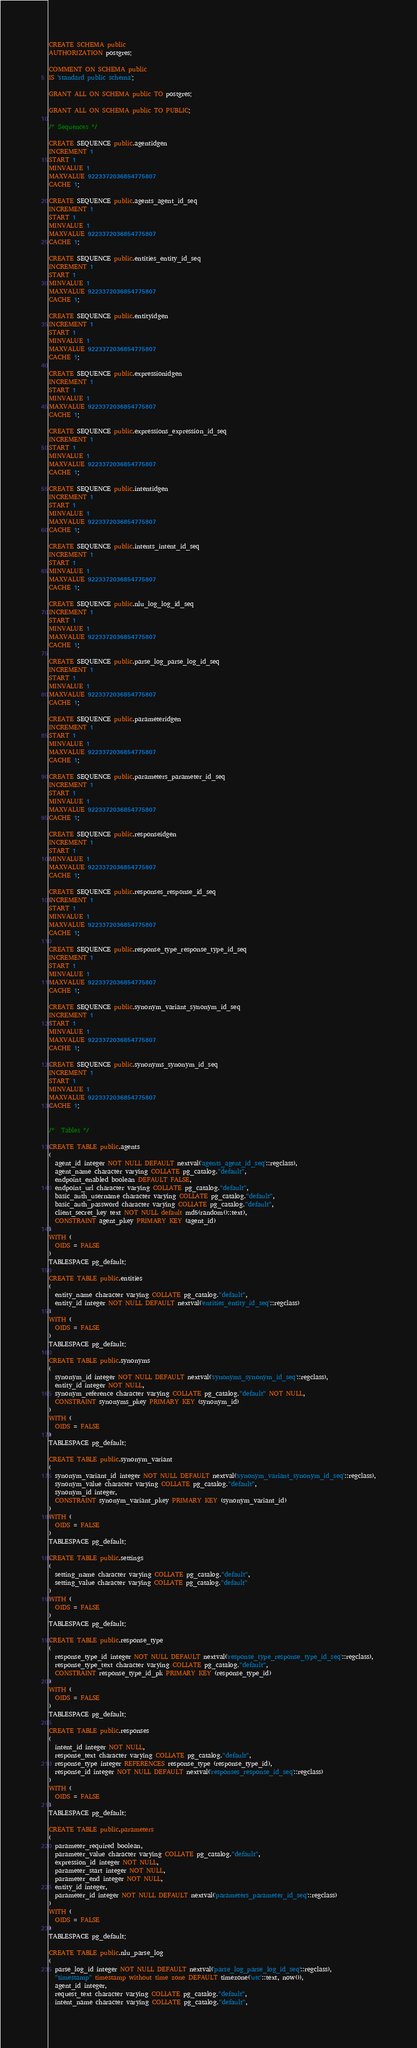Convert code to text. <code><loc_0><loc_0><loc_500><loc_500><_SQL_>CREATE SCHEMA public
AUTHORIZATION postgres;

COMMENT ON SCHEMA public
IS 'standard public schema';

GRANT ALL ON SCHEMA public TO postgres;

GRANT ALL ON SCHEMA public TO PUBLIC;

/* Sequences */

CREATE SEQUENCE public.agentidgen
INCREMENT 1
START 1
MINVALUE 1
MAXVALUE 9223372036854775807
CACHE 1;

CREATE SEQUENCE public.agents_agent_id_seq
INCREMENT 1
START 1
MINVALUE 1
MAXVALUE 9223372036854775807
CACHE 1;

CREATE SEQUENCE public.entities_entity_id_seq
INCREMENT 1
START 1
MINVALUE 1
MAXVALUE 9223372036854775807
CACHE 1;

CREATE SEQUENCE public.entityidgen
INCREMENT 1
START 1
MINVALUE 1
MAXVALUE 9223372036854775807
CACHE 1;

CREATE SEQUENCE public.expressionidgen
INCREMENT 1
START 1
MINVALUE 1
MAXVALUE 9223372036854775807
CACHE 1;

CREATE SEQUENCE public.expressions_expression_id_seq
INCREMENT 1
START 1
MINVALUE 1
MAXVALUE 9223372036854775807
CACHE 1;

CREATE SEQUENCE public.intentidgen
INCREMENT 1
START 1
MINVALUE 1
MAXVALUE 9223372036854775807
CACHE 1;

CREATE SEQUENCE public.intents_intent_id_seq
INCREMENT 1
START 1
MINVALUE 1
MAXVALUE 9223372036854775807
CACHE 1;

CREATE SEQUENCE public.nlu_log_log_id_seq
INCREMENT 1
START 1
MINVALUE 1
MAXVALUE 9223372036854775807
CACHE 1;

CREATE SEQUENCE public.parse_log_parse_log_id_seq
INCREMENT 1
START 1
MINVALUE 1
MAXVALUE 9223372036854775807
CACHE 1;

CREATE SEQUENCE public.parameteridgen
INCREMENT 1
START 1
MINVALUE 1
MAXVALUE 9223372036854775807
CACHE 1;

CREATE SEQUENCE public.parameters_parameter_id_seq
INCREMENT 1
START 1
MINVALUE 1
MAXVALUE 9223372036854775807
CACHE 1;

CREATE SEQUENCE public.responseidgen
INCREMENT 1
START 1
MINVALUE 1
MAXVALUE 9223372036854775807
CACHE 1;

CREATE SEQUENCE public.responses_response_id_seq
INCREMENT 1
START 1
MINVALUE 1
MAXVALUE 9223372036854775807
CACHE 1;

CREATE SEQUENCE public.response_type_response_type_id_seq
INCREMENT 1
START 1
MINVALUE 1
MAXVALUE 9223372036854775807
CACHE 1;

CREATE SEQUENCE public.synonym_variant_synonym_id_seq
INCREMENT 1
START 1
MINVALUE 1
MAXVALUE 9223372036854775807
CACHE 1;

CREATE SEQUENCE public.synonyms_synonym_id_seq
INCREMENT 1
START 1
MINVALUE 1
MAXVALUE 9223372036854775807
CACHE 1;


/*  Tables */

CREATE TABLE public.agents
(
  agent_id integer NOT NULL DEFAULT nextval('agents_agent_id_seq'::regclass),
  agent_name character varying COLLATE pg_catalog."default",
  endpoint_enabled boolean DEFAULT FALSE,
  endpoint_url character varying COLLATE pg_catalog."default",
  basic_auth_username character varying COLLATE pg_catalog."default",
  basic_auth_password character varying COLLATE pg_catalog."default",
  client_secret_key text NOT NULL default md5(random()::text),
  CONSTRAINT agent_pkey PRIMARY KEY (agent_id)
)
WITH (
  OIDS = FALSE
)
TABLESPACE pg_default;

CREATE TABLE public.entities
(
  entity_name character varying COLLATE pg_catalog."default",
  entity_id integer NOT NULL DEFAULT nextval('entities_entity_id_seq'::regclass)
)
WITH (
  OIDS = FALSE
)
TABLESPACE pg_default;

CREATE TABLE public.synonyms
(
  synonym_id integer NOT NULL DEFAULT nextval('synonyms_synonym_id_seq'::regclass),
  entity_id integer NOT NULL,
  synonym_reference character varying COLLATE pg_catalog."default" NOT NULL,
  CONSTRAINT synonyms_pkey PRIMARY KEY (synonym_id)
)
WITH (
  OIDS = FALSE
)
TABLESPACE pg_default;

CREATE TABLE public.synonym_variant
(
  synonym_variant_id integer NOT NULL DEFAULT nextval('synonym_variant_synonym_id_seq'::regclass),
  synonym_value character varying COLLATE pg_catalog."default",
  synonym_id integer,
  CONSTRAINT synonym_variant_pkey PRIMARY KEY (synonym_variant_id)
)
WITH (
  OIDS = FALSE
)
TABLESPACE pg_default;

CREATE TABLE public.settings
(
  setting_name character varying COLLATE pg_catalog."default",
  setting_value character varying COLLATE pg_catalog."default"
)
WITH (
  OIDS = FALSE
)
TABLESPACE pg_default;

CREATE TABLE public.response_type
(
  response_type_id integer NOT NULL DEFAULT nextval('response_type_response_type_id_seq'::regclass),
  response_type_text character varying COLLATE pg_catalog."default",
  CONSTRAINT response_type_id_pk PRIMARY KEY (response_type_id)
)
WITH (
  OIDS = FALSE
)
TABLESPACE pg_default;

CREATE TABLE public.responses
(
  intent_id integer NOT NULL,
  response_text character varying COLLATE pg_catalog."default",
  response_type integer REFERENCES response_type (response_type_id),
  response_id integer NOT NULL DEFAULT nextval('responses_response_id_seq'::regclass)
)
WITH (
  OIDS = FALSE
)
TABLESPACE pg_default;

CREATE TABLE public.parameters
(
  parameter_required boolean,
  parameter_value character varying COLLATE pg_catalog."default",
  expression_id integer NOT NULL,
  parameter_start integer NOT NULL,
  parameter_end integer NOT NULL,
  entity_id integer,
  parameter_id integer NOT NULL DEFAULT nextval('parameters_parameter_id_seq'::regclass)
)
WITH (
  OIDS = FALSE
)
TABLESPACE pg_default;

CREATE TABLE public.nlu_parse_log
(
  parse_log_id integer NOT NULL DEFAULT nextval('parse_log_parse_log_id_seq'::regclass),
  "timestamp" timestamp without time zone DEFAULT timezone('utc'::text, now()),
  agent_id integer,
  request_text character varying COLLATE pg_catalog."default",
  intent_name character varying COLLATE pg_catalog."default",</code> 